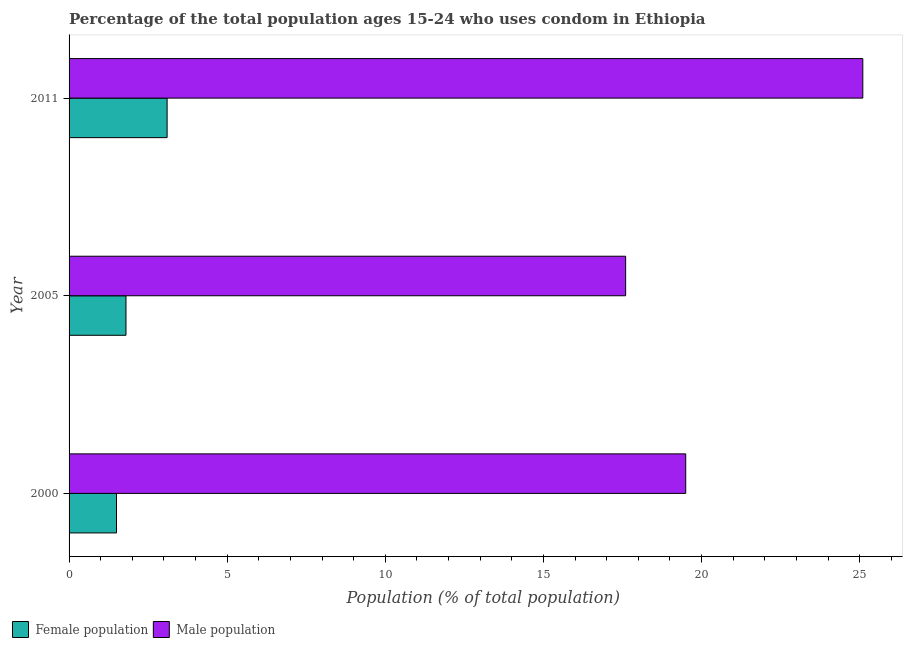How many groups of bars are there?
Your answer should be compact. 3. Are the number of bars per tick equal to the number of legend labels?
Give a very brief answer. Yes. How many bars are there on the 1st tick from the top?
Your answer should be very brief. 2. What is the label of the 2nd group of bars from the top?
Your answer should be compact. 2005. In how many cases, is the number of bars for a given year not equal to the number of legend labels?
Offer a terse response. 0. What is the male population in 2000?
Keep it short and to the point. 19.5. What is the total male population in the graph?
Offer a very short reply. 62.2. What is the difference between the male population in 2005 and the female population in 2011?
Provide a short and direct response. 14.5. What is the average male population per year?
Your answer should be very brief. 20.73. In how many years, is the female population greater than 23 %?
Your response must be concise. 0. What is the ratio of the male population in 2005 to that in 2011?
Provide a short and direct response. 0.7. Is the male population in 2000 less than that in 2005?
Keep it short and to the point. No. What is the difference between the highest and the lowest male population?
Your response must be concise. 7.5. In how many years, is the male population greater than the average male population taken over all years?
Ensure brevity in your answer.  1. What does the 2nd bar from the top in 2005 represents?
Make the answer very short. Female population. What does the 1st bar from the bottom in 2005 represents?
Offer a very short reply. Female population. Does the graph contain any zero values?
Your answer should be very brief. No. Where does the legend appear in the graph?
Offer a very short reply. Bottom left. How many legend labels are there?
Your answer should be very brief. 2. How are the legend labels stacked?
Your answer should be compact. Horizontal. What is the title of the graph?
Provide a succinct answer. Percentage of the total population ages 15-24 who uses condom in Ethiopia. Does "Secondary school" appear as one of the legend labels in the graph?
Your response must be concise. No. What is the label or title of the X-axis?
Your answer should be compact. Population (% of total population) . What is the label or title of the Y-axis?
Give a very brief answer. Year. What is the Population (% of total population)  in Male population in 2000?
Provide a succinct answer. 19.5. What is the Population (% of total population)  of Male population in 2011?
Make the answer very short. 25.1. Across all years, what is the maximum Population (% of total population)  in Male population?
Give a very brief answer. 25.1. Across all years, what is the minimum Population (% of total population)  in Female population?
Give a very brief answer. 1.5. Across all years, what is the minimum Population (% of total population)  in Male population?
Provide a succinct answer. 17.6. What is the total Population (% of total population)  of Male population in the graph?
Give a very brief answer. 62.2. What is the difference between the Population (% of total population)  in Female population in 2000 and that in 2005?
Give a very brief answer. -0.3. What is the difference between the Population (% of total population)  of Female population in 2000 and that in 2011?
Your answer should be compact. -1.6. What is the difference between the Population (% of total population)  of Female population in 2000 and the Population (% of total population)  of Male population in 2005?
Keep it short and to the point. -16.1. What is the difference between the Population (% of total population)  in Female population in 2000 and the Population (% of total population)  in Male population in 2011?
Provide a succinct answer. -23.6. What is the difference between the Population (% of total population)  of Female population in 2005 and the Population (% of total population)  of Male population in 2011?
Offer a terse response. -23.3. What is the average Population (% of total population)  in Female population per year?
Provide a short and direct response. 2.13. What is the average Population (% of total population)  in Male population per year?
Ensure brevity in your answer.  20.73. In the year 2005, what is the difference between the Population (% of total population)  of Female population and Population (% of total population)  of Male population?
Provide a succinct answer. -15.8. What is the ratio of the Population (% of total population)  in Male population in 2000 to that in 2005?
Provide a succinct answer. 1.11. What is the ratio of the Population (% of total population)  of Female population in 2000 to that in 2011?
Offer a terse response. 0.48. What is the ratio of the Population (% of total population)  of Male population in 2000 to that in 2011?
Give a very brief answer. 0.78. What is the ratio of the Population (% of total population)  in Female population in 2005 to that in 2011?
Offer a terse response. 0.58. What is the ratio of the Population (% of total population)  in Male population in 2005 to that in 2011?
Your answer should be very brief. 0.7. What is the difference between the highest and the second highest Population (% of total population)  of Male population?
Your answer should be very brief. 5.6. What is the difference between the highest and the lowest Population (% of total population)  in Female population?
Your answer should be compact. 1.6. What is the difference between the highest and the lowest Population (% of total population)  of Male population?
Provide a short and direct response. 7.5. 